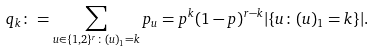Convert formula to latex. <formula><loc_0><loc_0><loc_500><loc_500>q _ { k } \colon = \sum _ { u \in \{ 1 , 2 \} ^ { r } \colon ( u ) _ { 1 } = k } p _ { u } = p ^ { k } ( 1 - p ) ^ { r - k } | \{ u \colon ( u ) _ { 1 } = k \} | .</formula> 